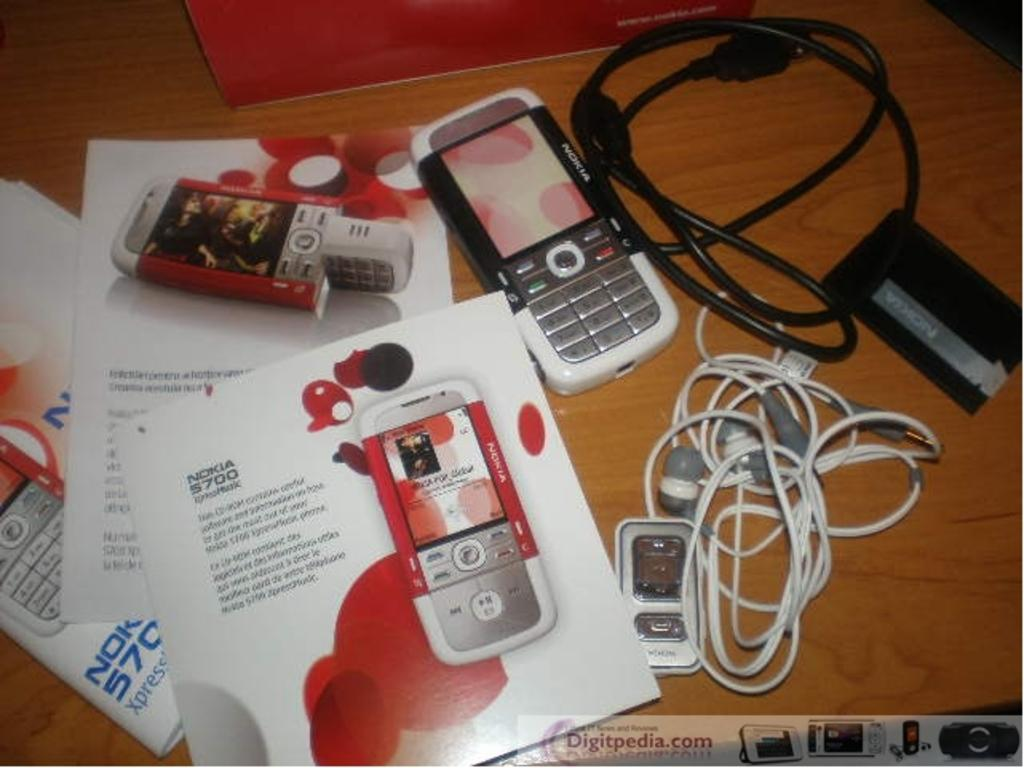<image>
Present a compact description of the photo's key features. A Nokia phone and paperwork for it with some other cords. 